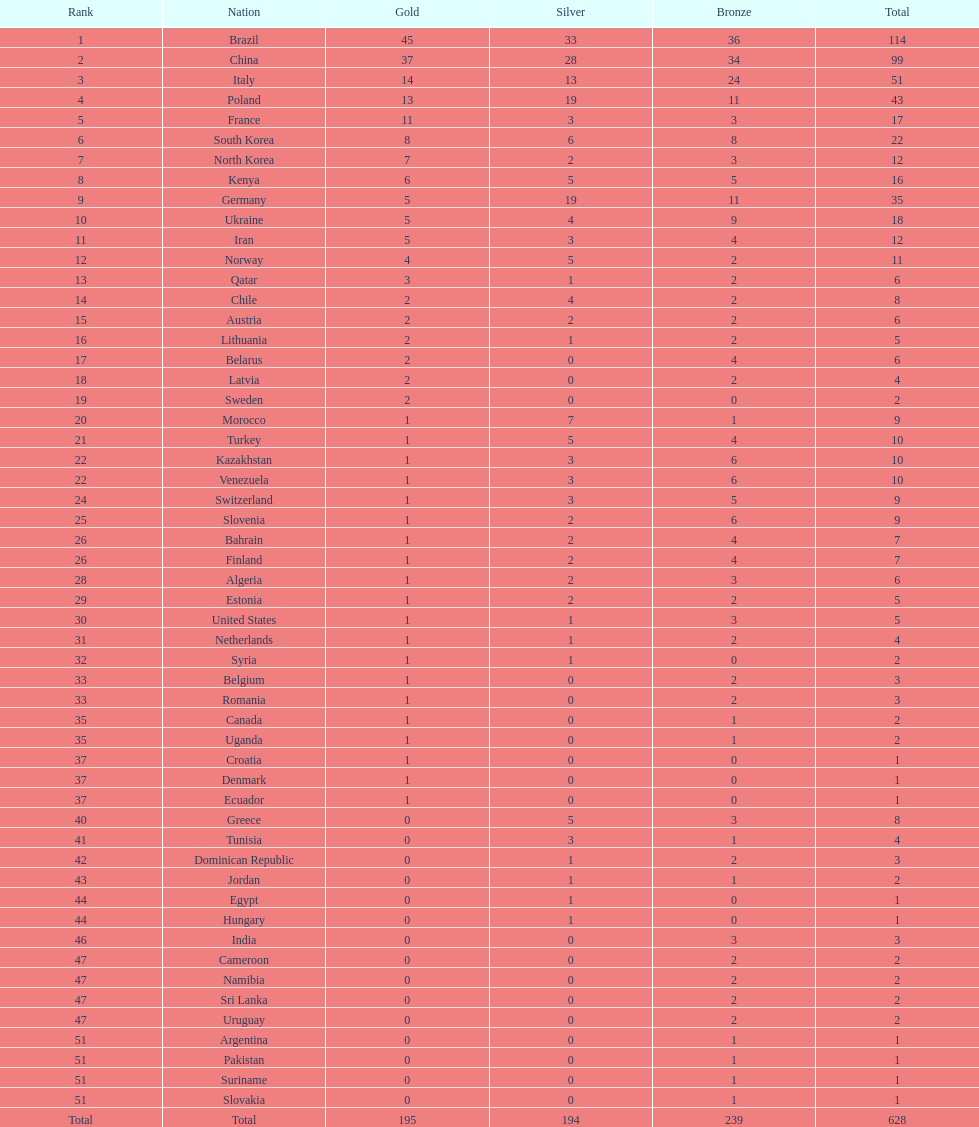Would you be able to parse every entry in this table? {'header': ['Rank', 'Nation', 'Gold', 'Silver', 'Bronze', 'Total'], 'rows': [['1', 'Brazil', '45', '33', '36', '114'], ['2', 'China', '37', '28', '34', '99'], ['3', 'Italy', '14', '13', '24', '51'], ['4', 'Poland', '13', '19', '11', '43'], ['5', 'France', '11', '3', '3', '17'], ['6', 'South Korea', '8', '6', '8', '22'], ['7', 'North Korea', '7', '2', '3', '12'], ['8', 'Kenya', '6', '5', '5', '16'], ['9', 'Germany', '5', '19', '11', '35'], ['10', 'Ukraine', '5', '4', '9', '18'], ['11', 'Iran', '5', '3', '4', '12'], ['12', 'Norway', '4', '5', '2', '11'], ['13', 'Qatar', '3', '1', '2', '6'], ['14', 'Chile', '2', '4', '2', '8'], ['15', 'Austria', '2', '2', '2', '6'], ['16', 'Lithuania', '2', '1', '2', '5'], ['17', 'Belarus', '2', '0', '4', '6'], ['18', 'Latvia', '2', '0', '2', '4'], ['19', 'Sweden', '2', '0', '0', '2'], ['20', 'Morocco', '1', '7', '1', '9'], ['21', 'Turkey', '1', '5', '4', '10'], ['22', 'Kazakhstan', '1', '3', '6', '10'], ['22', 'Venezuela', '1', '3', '6', '10'], ['24', 'Switzerland', '1', '3', '5', '9'], ['25', 'Slovenia', '1', '2', '6', '9'], ['26', 'Bahrain', '1', '2', '4', '7'], ['26', 'Finland', '1', '2', '4', '7'], ['28', 'Algeria', '1', '2', '3', '6'], ['29', 'Estonia', '1', '2', '2', '5'], ['30', 'United States', '1', '1', '3', '5'], ['31', 'Netherlands', '1', '1', '2', '4'], ['32', 'Syria', '1', '1', '0', '2'], ['33', 'Belgium', '1', '0', '2', '3'], ['33', 'Romania', '1', '0', '2', '3'], ['35', 'Canada', '1', '0', '1', '2'], ['35', 'Uganda', '1', '0', '1', '2'], ['37', 'Croatia', '1', '0', '0', '1'], ['37', 'Denmark', '1', '0', '0', '1'], ['37', 'Ecuador', '1', '0', '0', '1'], ['40', 'Greece', '0', '5', '3', '8'], ['41', 'Tunisia', '0', '3', '1', '4'], ['42', 'Dominican Republic', '0', '1', '2', '3'], ['43', 'Jordan', '0', '1', '1', '2'], ['44', 'Egypt', '0', '1', '0', '1'], ['44', 'Hungary', '0', '1', '0', '1'], ['46', 'India', '0', '0', '3', '3'], ['47', 'Cameroon', '0', '0', '2', '2'], ['47', 'Namibia', '0', '0', '2', '2'], ['47', 'Sri Lanka', '0', '0', '2', '2'], ['47', 'Uruguay', '0', '0', '2', '2'], ['51', 'Argentina', '0', '0', '1', '1'], ['51', 'Pakistan', '0', '0', '1', '1'], ['51', 'Suriname', '0', '0', '1', '1'], ['51', 'Slovakia', '0', '0', '1', '1'], ['Total', 'Total', '195', '194', '239', '628']]} Which country secured the maximum gold medals? Brazil. 